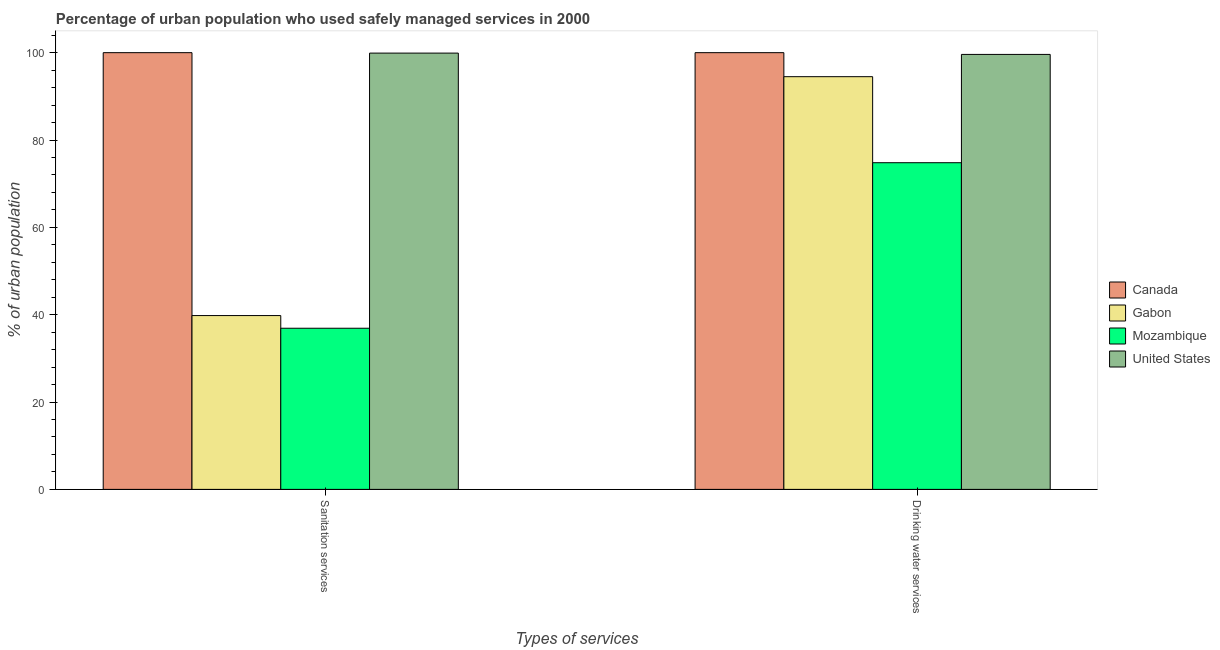How many different coloured bars are there?
Your answer should be compact. 4. How many groups of bars are there?
Your answer should be very brief. 2. Are the number of bars per tick equal to the number of legend labels?
Ensure brevity in your answer.  Yes. What is the label of the 2nd group of bars from the left?
Your answer should be very brief. Drinking water services. Across all countries, what is the maximum percentage of urban population who used drinking water services?
Offer a very short reply. 100. Across all countries, what is the minimum percentage of urban population who used sanitation services?
Offer a very short reply. 36.9. In which country was the percentage of urban population who used sanitation services maximum?
Offer a terse response. Canada. In which country was the percentage of urban population who used sanitation services minimum?
Make the answer very short. Mozambique. What is the total percentage of urban population who used sanitation services in the graph?
Your response must be concise. 276.6. What is the difference between the percentage of urban population who used sanitation services in United States and that in Mozambique?
Offer a terse response. 63. What is the difference between the percentage of urban population who used drinking water services in United States and the percentage of urban population who used sanitation services in Canada?
Ensure brevity in your answer.  -0.4. What is the average percentage of urban population who used drinking water services per country?
Your answer should be very brief. 92.22. What is the difference between the percentage of urban population who used sanitation services and percentage of urban population who used drinking water services in United States?
Make the answer very short. 0.3. What is the ratio of the percentage of urban population who used drinking water services in Gabon to that in United States?
Provide a succinct answer. 0.95. Is the percentage of urban population who used drinking water services in Mozambique less than that in Gabon?
Give a very brief answer. Yes. What does the 2nd bar from the left in Drinking water services represents?
Offer a terse response. Gabon. How many countries are there in the graph?
Provide a succinct answer. 4. What is the difference between two consecutive major ticks on the Y-axis?
Your response must be concise. 20. Does the graph contain any zero values?
Your answer should be compact. No. Does the graph contain grids?
Make the answer very short. No. How are the legend labels stacked?
Your answer should be very brief. Vertical. What is the title of the graph?
Make the answer very short. Percentage of urban population who used safely managed services in 2000. What is the label or title of the X-axis?
Offer a very short reply. Types of services. What is the label or title of the Y-axis?
Your response must be concise. % of urban population. What is the % of urban population in Canada in Sanitation services?
Offer a terse response. 100. What is the % of urban population in Gabon in Sanitation services?
Your answer should be compact. 39.8. What is the % of urban population in Mozambique in Sanitation services?
Offer a terse response. 36.9. What is the % of urban population of United States in Sanitation services?
Your answer should be compact. 99.9. What is the % of urban population of Gabon in Drinking water services?
Your answer should be compact. 94.5. What is the % of urban population in Mozambique in Drinking water services?
Make the answer very short. 74.8. What is the % of urban population of United States in Drinking water services?
Provide a succinct answer. 99.6. Across all Types of services, what is the maximum % of urban population in Gabon?
Give a very brief answer. 94.5. Across all Types of services, what is the maximum % of urban population in Mozambique?
Offer a very short reply. 74.8. Across all Types of services, what is the maximum % of urban population in United States?
Offer a very short reply. 99.9. Across all Types of services, what is the minimum % of urban population of Canada?
Ensure brevity in your answer.  100. Across all Types of services, what is the minimum % of urban population of Gabon?
Give a very brief answer. 39.8. Across all Types of services, what is the minimum % of urban population of Mozambique?
Your response must be concise. 36.9. Across all Types of services, what is the minimum % of urban population of United States?
Offer a terse response. 99.6. What is the total % of urban population of Gabon in the graph?
Keep it short and to the point. 134.3. What is the total % of urban population of Mozambique in the graph?
Your answer should be compact. 111.7. What is the total % of urban population in United States in the graph?
Your answer should be compact. 199.5. What is the difference between the % of urban population in Canada in Sanitation services and that in Drinking water services?
Provide a succinct answer. 0. What is the difference between the % of urban population in Gabon in Sanitation services and that in Drinking water services?
Your answer should be compact. -54.7. What is the difference between the % of urban population of Mozambique in Sanitation services and that in Drinking water services?
Provide a short and direct response. -37.9. What is the difference between the % of urban population of Canada in Sanitation services and the % of urban population of Gabon in Drinking water services?
Offer a terse response. 5.5. What is the difference between the % of urban population of Canada in Sanitation services and the % of urban population of Mozambique in Drinking water services?
Ensure brevity in your answer.  25.2. What is the difference between the % of urban population in Canada in Sanitation services and the % of urban population in United States in Drinking water services?
Your response must be concise. 0.4. What is the difference between the % of urban population in Gabon in Sanitation services and the % of urban population in Mozambique in Drinking water services?
Ensure brevity in your answer.  -35. What is the difference between the % of urban population in Gabon in Sanitation services and the % of urban population in United States in Drinking water services?
Give a very brief answer. -59.8. What is the difference between the % of urban population in Mozambique in Sanitation services and the % of urban population in United States in Drinking water services?
Keep it short and to the point. -62.7. What is the average % of urban population in Canada per Types of services?
Provide a short and direct response. 100. What is the average % of urban population in Gabon per Types of services?
Your response must be concise. 67.15. What is the average % of urban population in Mozambique per Types of services?
Your answer should be compact. 55.85. What is the average % of urban population of United States per Types of services?
Provide a succinct answer. 99.75. What is the difference between the % of urban population in Canada and % of urban population in Gabon in Sanitation services?
Keep it short and to the point. 60.2. What is the difference between the % of urban population in Canada and % of urban population in Mozambique in Sanitation services?
Ensure brevity in your answer.  63.1. What is the difference between the % of urban population in Canada and % of urban population in United States in Sanitation services?
Provide a short and direct response. 0.1. What is the difference between the % of urban population in Gabon and % of urban population in Mozambique in Sanitation services?
Offer a very short reply. 2.9. What is the difference between the % of urban population of Gabon and % of urban population of United States in Sanitation services?
Make the answer very short. -60.1. What is the difference between the % of urban population of Mozambique and % of urban population of United States in Sanitation services?
Make the answer very short. -63. What is the difference between the % of urban population in Canada and % of urban population in Mozambique in Drinking water services?
Ensure brevity in your answer.  25.2. What is the difference between the % of urban population in Canada and % of urban population in United States in Drinking water services?
Keep it short and to the point. 0.4. What is the difference between the % of urban population of Gabon and % of urban population of Mozambique in Drinking water services?
Provide a succinct answer. 19.7. What is the difference between the % of urban population of Mozambique and % of urban population of United States in Drinking water services?
Offer a very short reply. -24.8. What is the ratio of the % of urban population in Gabon in Sanitation services to that in Drinking water services?
Provide a short and direct response. 0.42. What is the ratio of the % of urban population of Mozambique in Sanitation services to that in Drinking water services?
Give a very brief answer. 0.49. What is the difference between the highest and the second highest % of urban population of Gabon?
Your answer should be very brief. 54.7. What is the difference between the highest and the second highest % of urban population of Mozambique?
Offer a very short reply. 37.9. What is the difference between the highest and the lowest % of urban population of Gabon?
Offer a terse response. 54.7. What is the difference between the highest and the lowest % of urban population in Mozambique?
Give a very brief answer. 37.9. 